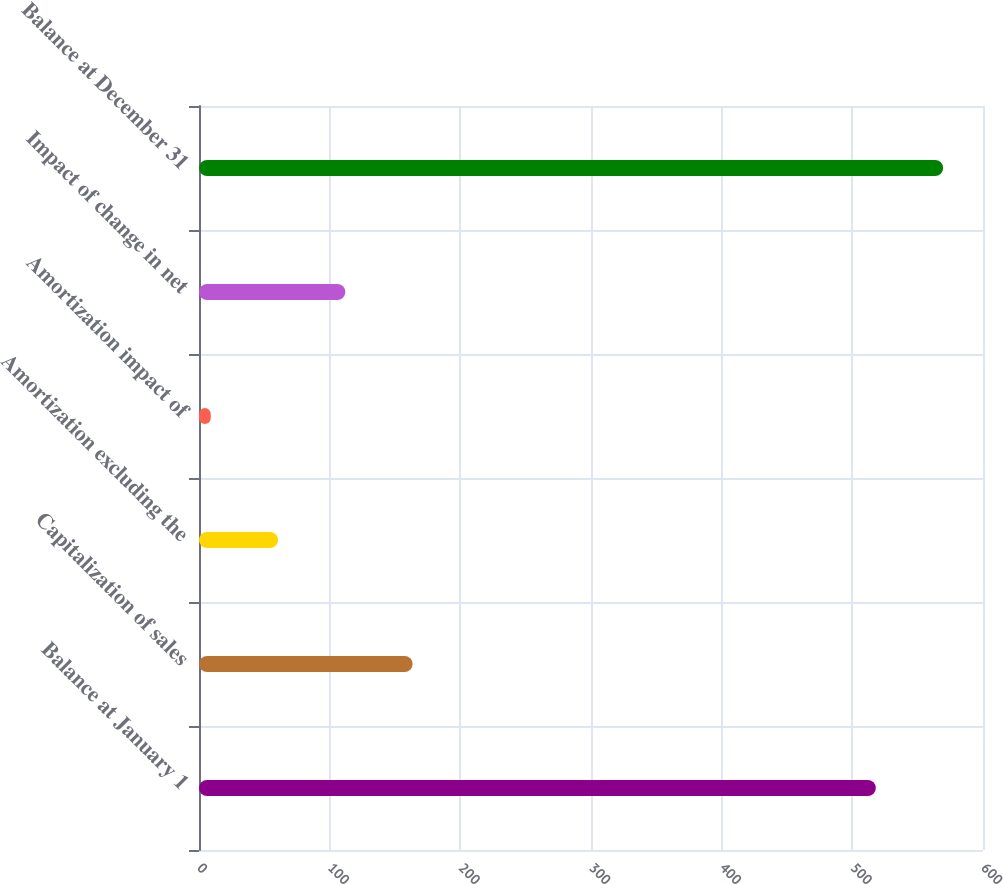<chart> <loc_0><loc_0><loc_500><loc_500><bar_chart><fcel>Balance at January 1<fcel>Capitalization of sales<fcel>Amortization excluding the<fcel>Amortization impact of<fcel>Impact of change in net<fcel>Balance at December 31<nl><fcel>518<fcel>163.5<fcel>60.5<fcel>9<fcel>112<fcel>569.5<nl></chart> 